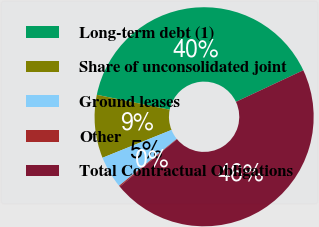Convert chart. <chart><loc_0><loc_0><loc_500><loc_500><pie_chart><fcel>Long-term debt (1)<fcel>Share of unconsolidated joint<fcel>Ground leases<fcel>Other<fcel>Total Contractual Obligations<nl><fcel>39.8%<fcel>9.32%<fcel>4.74%<fcel>0.16%<fcel>45.97%<nl></chart> 